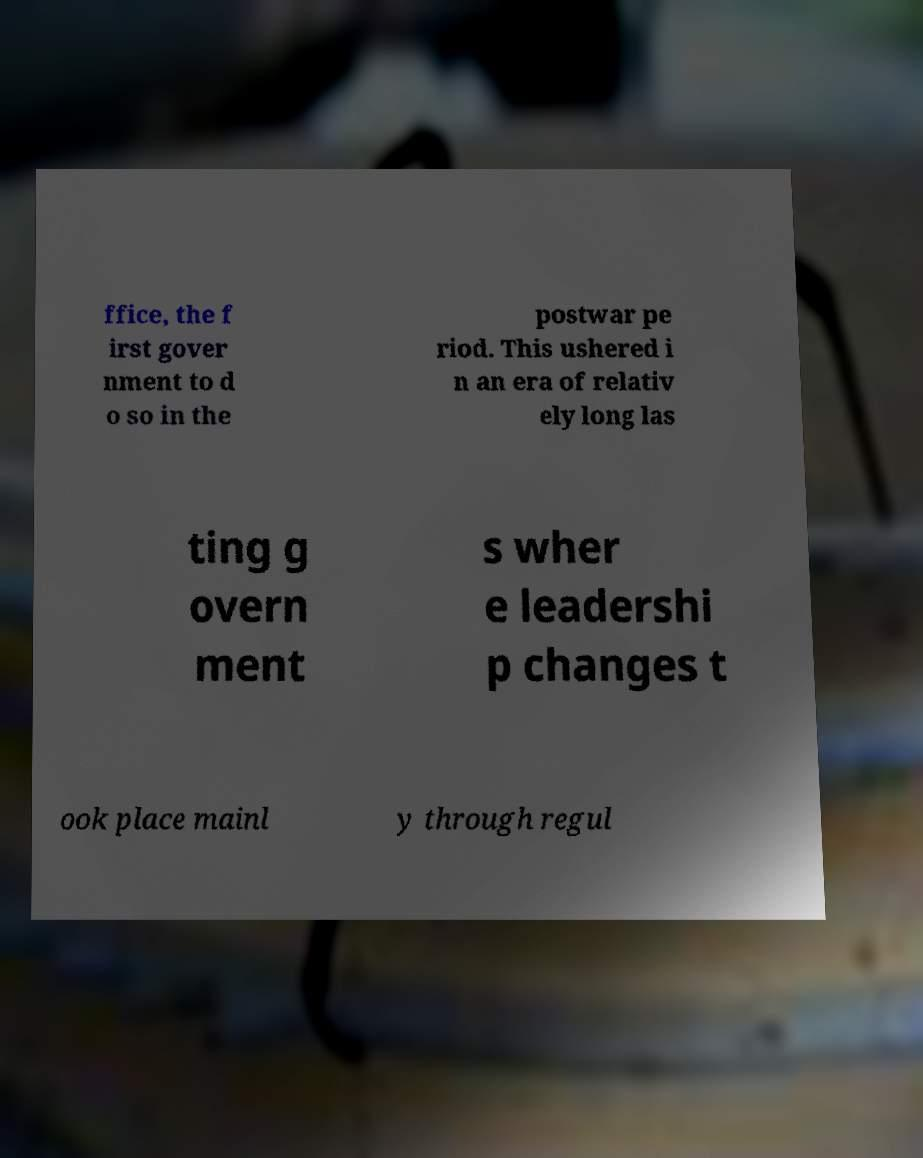Please identify and transcribe the text found in this image. ffice, the f irst gover nment to d o so in the postwar pe riod. This ushered i n an era of relativ ely long las ting g overn ment s wher e leadershi p changes t ook place mainl y through regul 